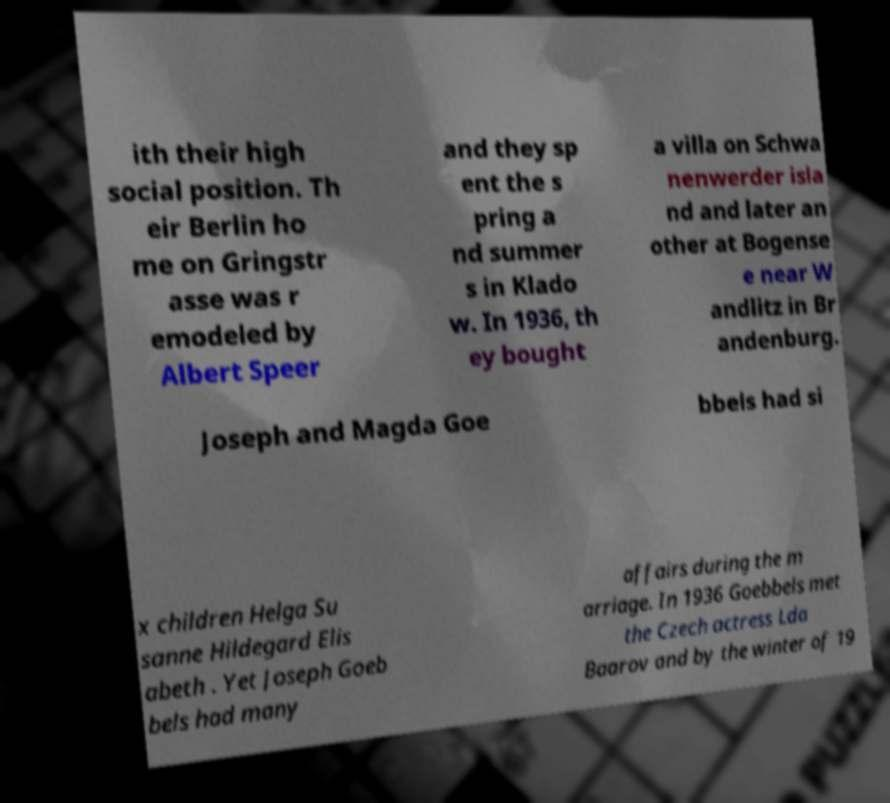What messages or text are displayed in this image? I need them in a readable, typed format. ith their high social position. Th eir Berlin ho me on Gringstr asse was r emodeled by Albert Speer and they sp ent the s pring a nd summer s in Klado w. In 1936, th ey bought a villa on Schwa nenwerder isla nd and later an other at Bogense e near W andlitz in Br andenburg. Joseph and Magda Goe bbels had si x children Helga Su sanne Hildegard Elis abeth . Yet Joseph Goeb bels had many affairs during the m arriage. In 1936 Goebbels met the Czech actress Lda Baarov and by the winter of 19 